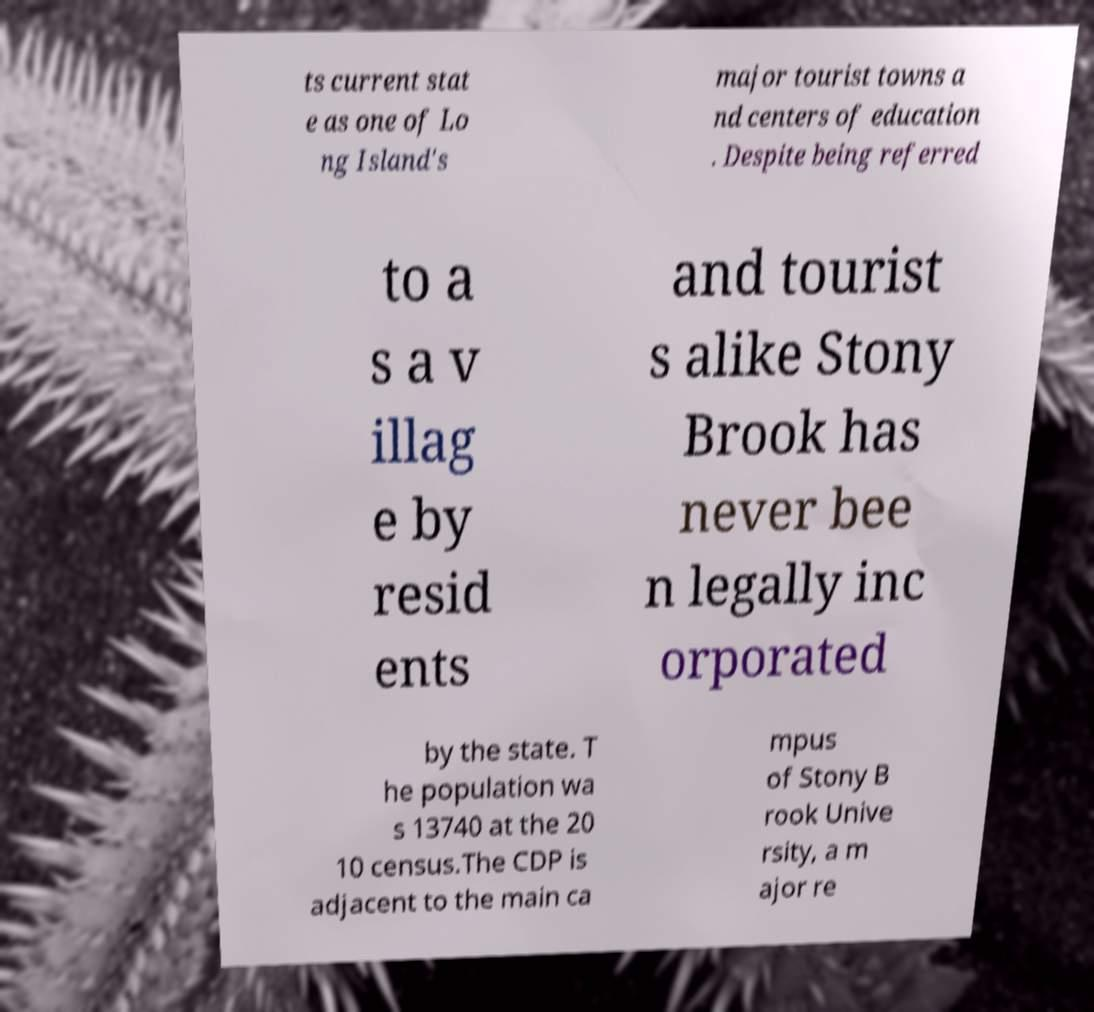There's text embedded in this image that I need extracted. Can you transcribe it verbatim? ts current stat e as one of Lo ng Island's major tourist towns a nd centers of education . Despite being referred to a s a v illag e by resid ents and tourist s alike Stony Brook has never bee n legally inc orporated by the state. T he population wa s 13740 at the 20 10 census.The CDP is adjacent to the main ca mpus of Stony B rook Unive rsity, a m ajor re 